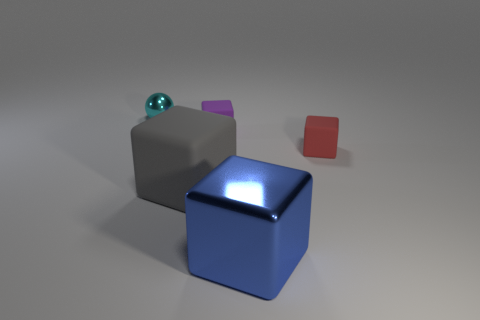Add 3 small blocks. How many objects exist? 8 Subtract all balls. How many objects are left? 4 Subtract 0 red spheres. How many objects are left? 5 Subtract all tiny cyan balls. Subtract all blue metallic blocks. How many objects are left? 3 Add 2 big rubber objects. How many big rubber objects are left? 3 Add 3 large yellow shiny cubes. How many large yellow shiny cubes exist? 3 